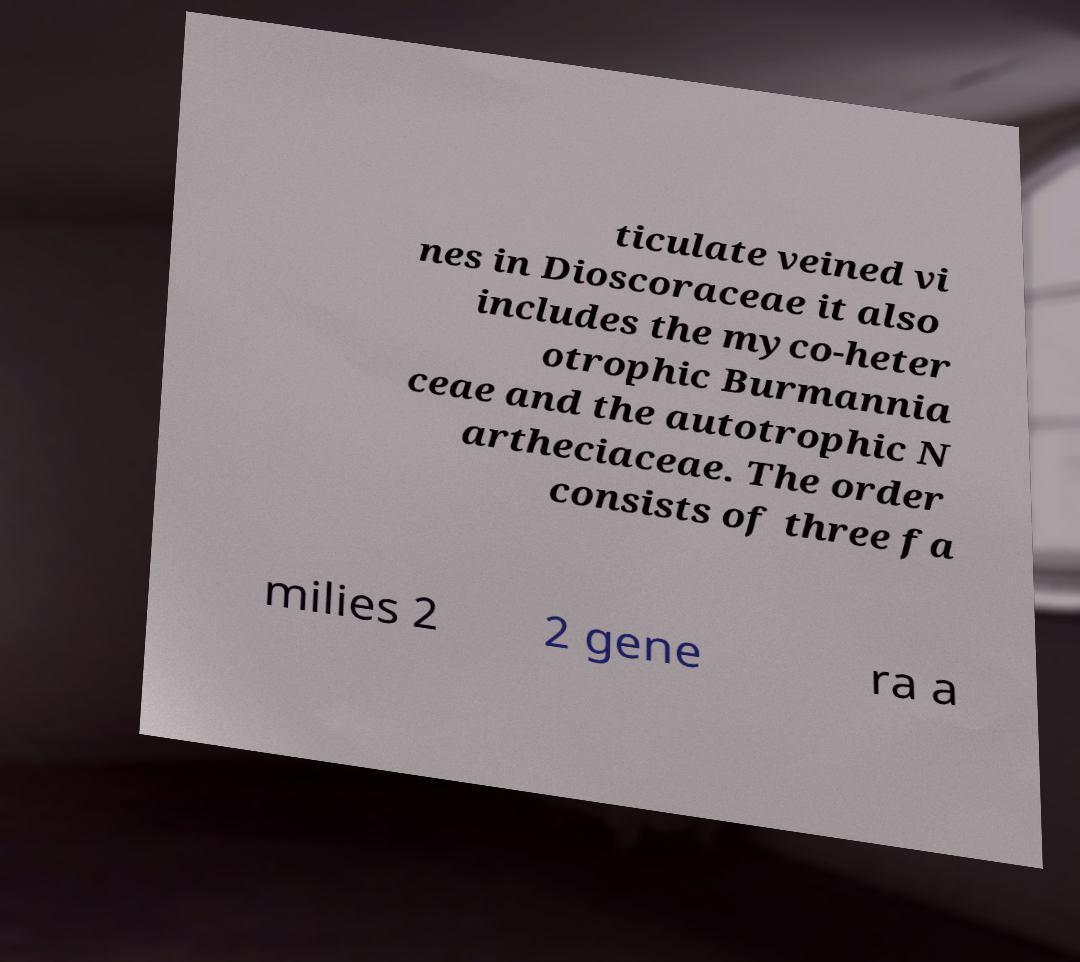Please identify and transcribe the text found in this image. ticulate veined vi nes in Dioscoraceae it also includes the myco-heter otrophic Burmannia ceae and the autotrophic N artheciaceae. The order consists of three fa milies 2 2 gene ra a 